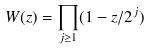Convert formula to latex. <formula><loc_0><loc_0><loc_500><loc_500>W ( z ) = \prod _ { j \geq 1 } ( 1 - z / 2 ^ { j } )</formula> 